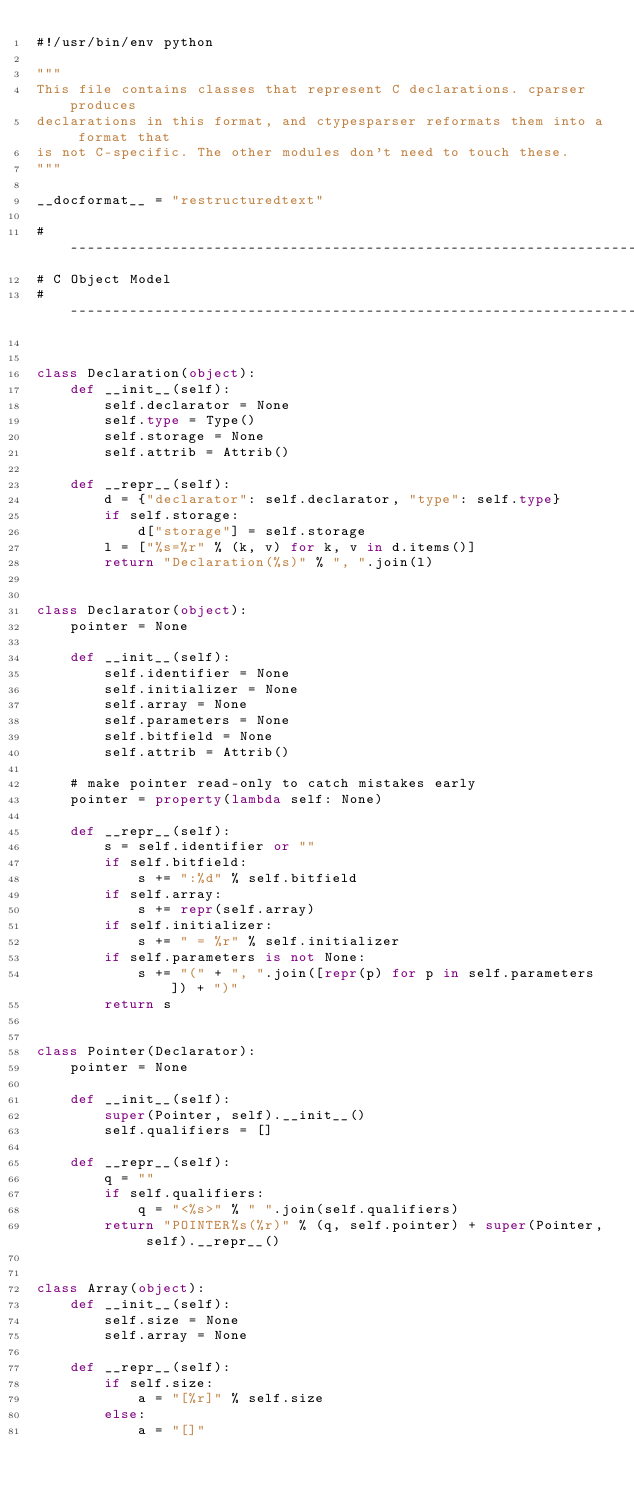Convert code to text. <code><loc_0><loc_0><loc_500><loc_500><_Python_>#!/usr/bin/env python

"""
This file contains classes that represent C declarations. cparser produces
declarations in this format, and ctypesparser reformats them into a format that
is not C-specific. The other modules don't need to touch these.
"""

__docformat__ = "restructuredtext"

# --------------------------------------------------------------------------
# C Object Model
# --------------------------------------------------------------------------


class Declaration(object):
    def __init__(self):
        self.declarator = None
        self.type = Type()
        self.storage = None
        self.attrib = Attrib()

    def __repr__(self):
        d = {"declarator": self.declarator, "type": self.type}
        if self.storage:
            d["storage"] = self.storage
        l = ["%s=%r" % (k, v) for k, v in d.items()]
        return "Declaration(%s)" % ", ".join(l)


class Declarator(object):
    pointer = None

    def __init__(self):
        self.identifier = None
        self.initializer = None
        self.array = None
        self.parameters = None
        self.bitfield = None
        self.attrib = Attrib()

    # make pointer read-only to catch mistakes early
    pointer = property(lambda self: None)

    def __repr__(self):
        s = self.identifier or ""
        if self.bitfield:
            s += ":%d" % self.bitfield
        if self.array:
            s += repr(self.array)
        if self.initializer:
            s += " = %r" % self.initializer
        if self.parameters is not None:
            s += "(" + ", ".join([repr(p) for p in self.parameters]) + ")"
        return s


class Pointer(Declarator):
    pointer = None

    def __init__(self):
        super(Pointer, self).__init__()
        self.qualifiers = []

    def __repr__(self):
        q = ""
        if self.qualifiers:
            q = "<%s>" % " ".join(self.qualifiers)
        return "POINTER%s(%r)" % (q, self.pointer) + super(Pointer, self).__repr__()


class Array(object):
    def __init__(self):
        self.size = None
        self.array = None

    def __repr__(self):
        if self.size:
            a = "[%r]" % self.size
        else:
            a = "[]"</code> 